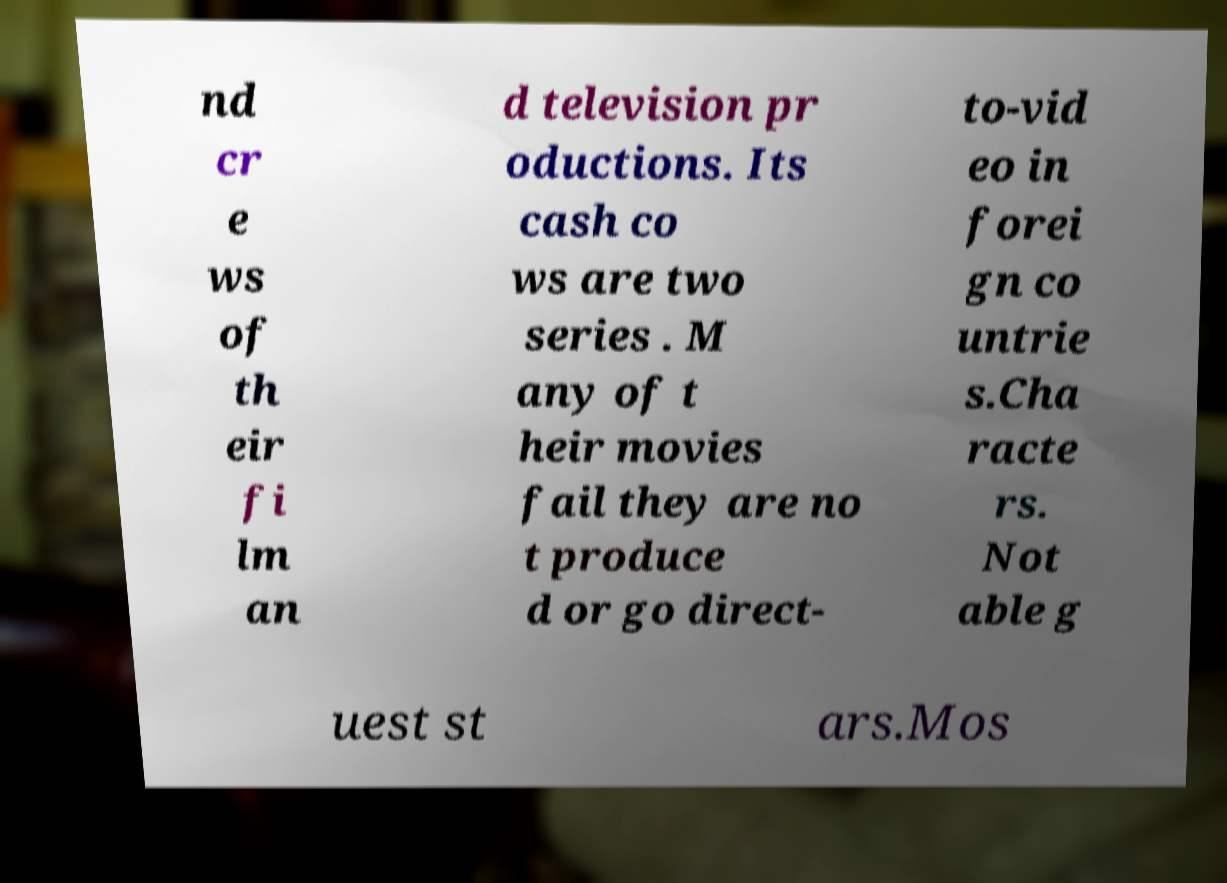For documentation purposes, I need the text within this image transcribed. Could you provide that? nd cr e ws of th eir fi lm an d television pr oductions. Its cash co ws are two series . M any of t heir movies fail they are no t produce d or go direct- to-vid eo in forei gn co untrie s.Cha racte rs. Not able g uest st ars.Mos 